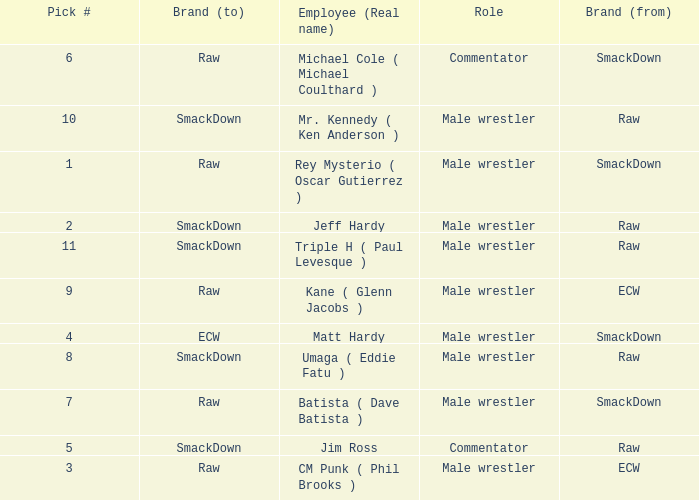Pick # 3 works for which brand? ECW. Parse the full table. {'header': ['Pick #', 'Brand (to)', 'Employee (Real name)', 'Role', 'Brand (from)'], 'rows': [['6', 'Raw', 'Michael Cole ( Michael Coulthard )', 'Commentator', 'SmackDown'], ['10', 'SmackDown', 'Mr. Kennedy ( Ken Anderson )', 'Male wrestler', 'Raw'], ['1', 'Raw', 'Rey Mysterio ( Oscar Gutierrez )', 'Male wrestler', 'SmackDown'], ['2', 'SmackDown', 'Jeff Hardy', 'Male wrestler', 'Raw'], ['11', 'SmackDown', 'Triple H ( Paul Levesque )', 'Male wrestler', 'Raw'], ['9', 'Raw', 'Kane ( Glenn Jacobs )', 'Male wrestler', 'ECW'], ['4', 'ECW', 'Matt Hardy', 'Male wrestler', 'SmackDown'], ['8', 'SmackDown', 'Umaga ( Eddie Fatu )', 'Male wrestler', 'Raw'], ['7', 'Raw', 'Batista ( Dave Batista )', 'Male wrestler', 'SmackDown'], ['5', 'SmackDown', 'Jim Ross', 'Commentator', 'Raw'], ['3', 'Raw', 'CM Punk ( Phil Brooks )', 'Male wrestler', 'ECW']]} 